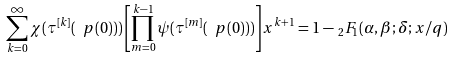Convert formula to latex. <formula><loc_0><loc_0><loc_500><loc_500>\sum _ { k = 0 } ^ { \infty } \chi ( \tau ^ { [ k ] } ( \ p ( 0 ) ) ) \left [ \prod _ { m = 0 } ^ { k - 1 } \psi ( \tau ^ { [ m ] } ( \ p ( 0 ) ) ) \right ] x ^ { k + 1 } = 1 - \, _ { 2 } F _ { 1 } ( \alpha , \beta ; \delta ; x / q )</formula> 